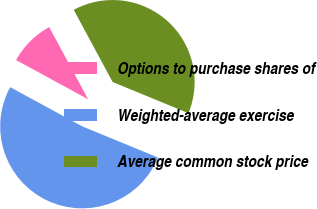<chart> <loc_0><loc_0><loc_500><loc_500><pie_chart><fcel>Options to purchase shares of<fcel>Weighted-average exercise<fcel>Average common stock price<nl><fcel>9.2%<fcel>51.72%<fcel>39.08%<nl></chart> 